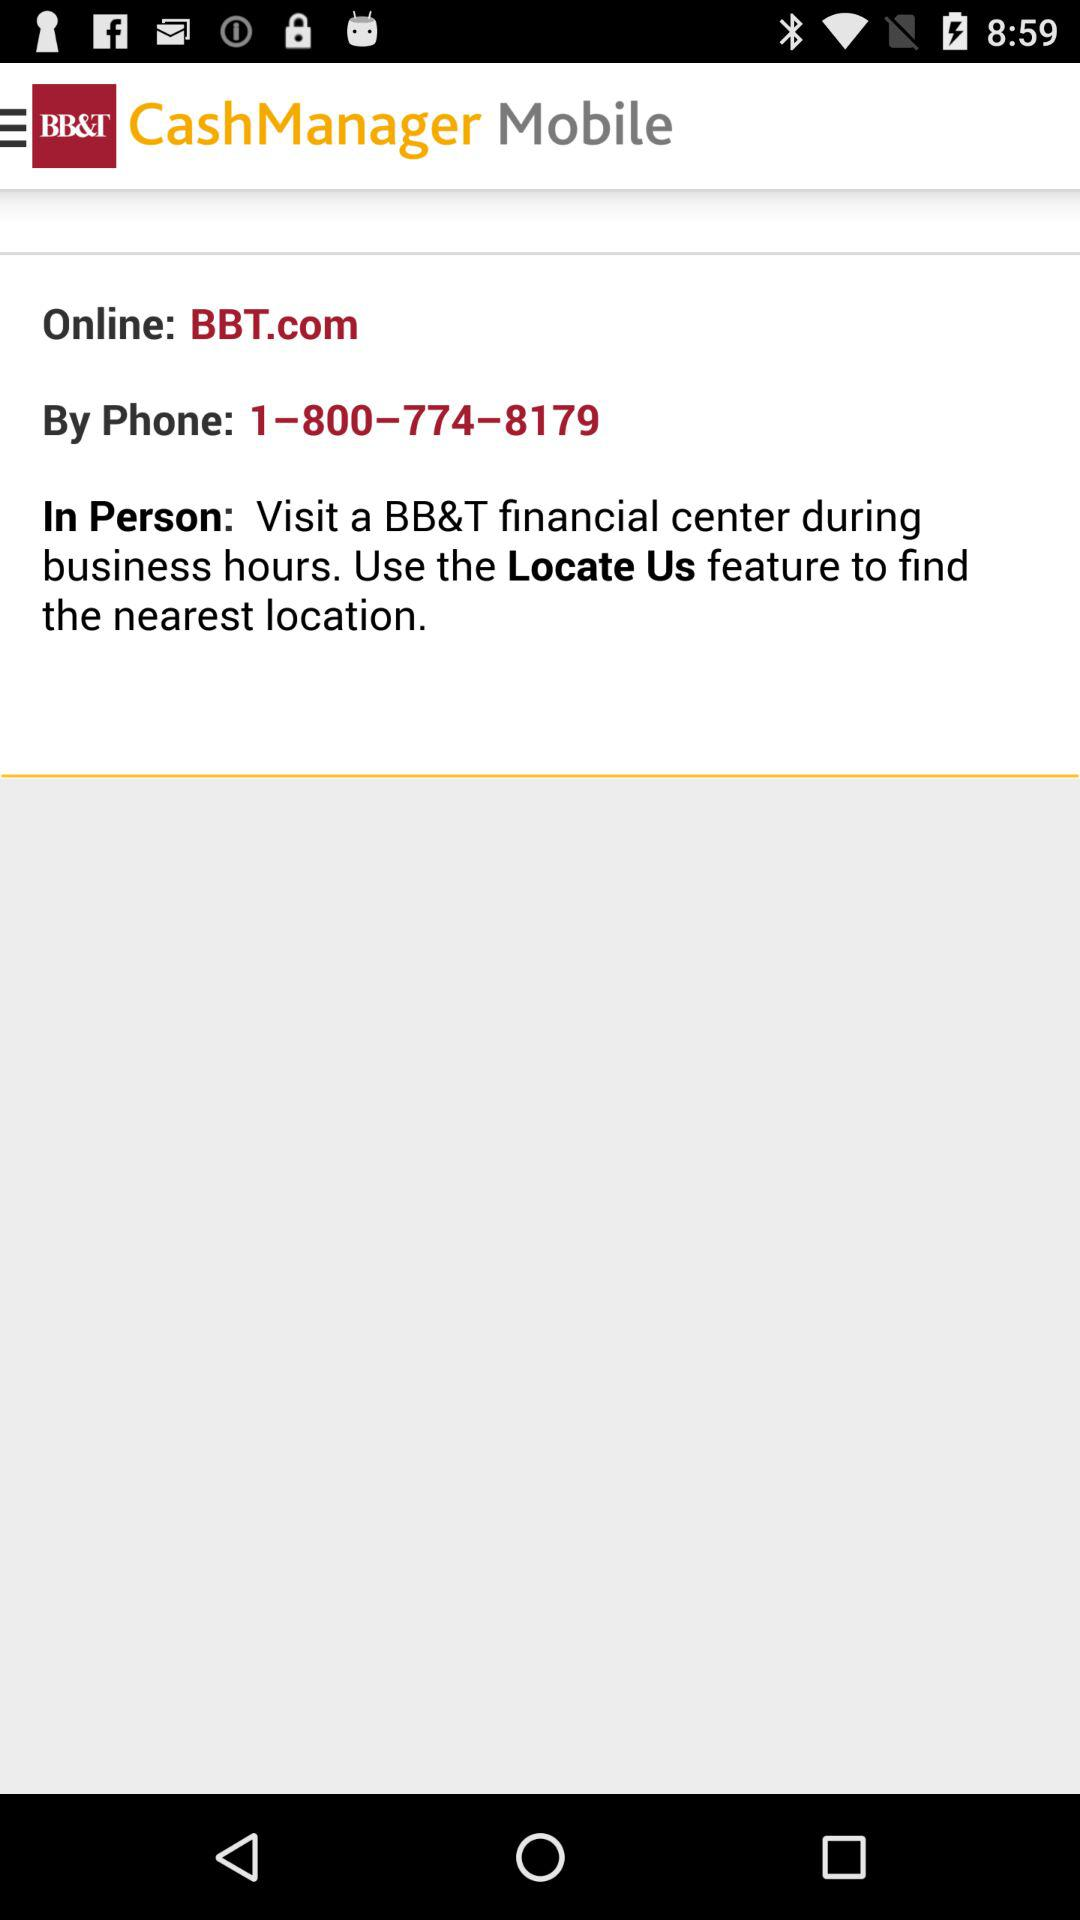What is the "Online" website? The "Online" website is BBT.com. 